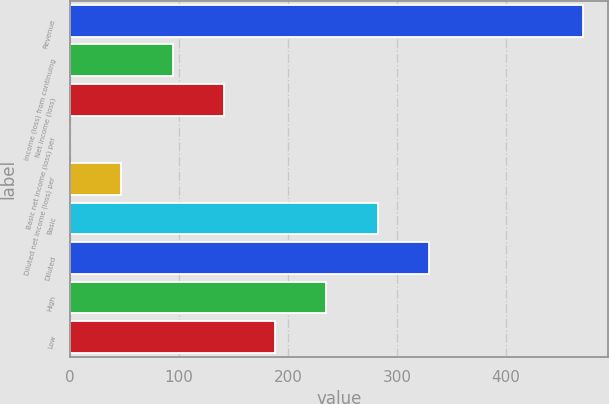Convert chart to OTSL. <chart><loc_0><loc_0><loc_500><loc_500><bar_chart><fcel>Revenue<fcel>Income (loss) from continuing<fcel>Net income (loss)<fcel>Basic net income (loss) per<fcel>Diluted net income (loss) per<fcel>Basic<fcel>Diluted<fcel>High<fcel>Low<nl><fcel>470.5<fcel>94.18<fcel>141.22<fcel>0.1<fcel>47.14<fcel>282.34<fcel>329.38<fcel>235.3<fcel>188.26<nl></chart> 